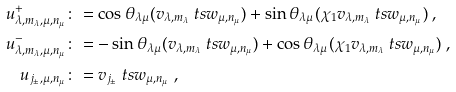<formula> <loc_0><loc_0><loc_500><loc_500>u _ { \lambda , m _ { \lambda } , \mu , n _ { \mu } } ^ { + } & \colon = \cos \theta _ { \lambda \mu } ( v _ { \lambda , m _ { \lambda } } \ t s w _ { \mu , n _ { \mu } } ) + \sin \theta _ { \lambda \mu } ( \chi _ { 1 } v _ { \lambda , m _ { \lambda } } \ t s w _ { \mu , n _ { \mu } } ) \ , \\ u _ { \lambda , m _ { \lambda } , \mu , n _ { \mu } } ^ { - } & \colon = - \sin \theta _ { \lambda \mu } ( v _ { \lambda , m _ { \lambda } } \ t s w _ { \mu , n _ { \mu } } ) + \cos \theta _ { \lambda \mu } ( \chi _ { 1 } v _ { \lambda , m _ { \lambda } } \ t s w _ { \mu , n _ { \mu } } ) \ , \\ u _ { j _ { \pm } , \mu , n _ { \mu } } & \colon = v _ { j _ { \pm } } \ t s w _ { \mu , n _ { \mu } } \ ,</formula> 